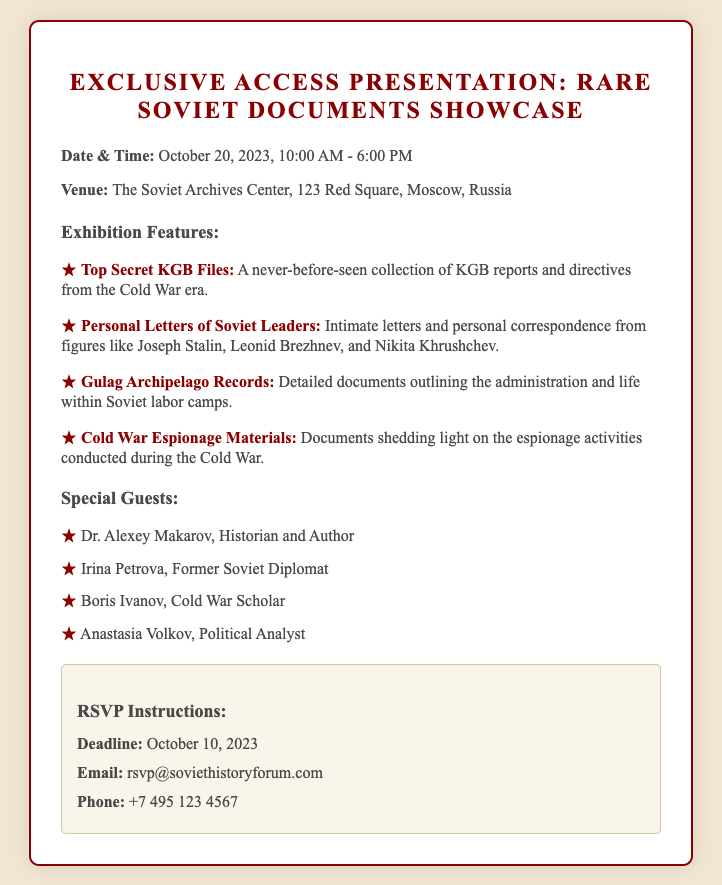what is the date of the event? The date of the event is explicitly stated in the document.
Answer: October 20, 2023 what time does the exhibition start? The exhibition hours are listed at the beginning of the document.
Answer: 10:00 AM who is one of the special guests? The document lists several special guests in a bullet format.
Answer: Dr. Alexey Makarov what type of documents are featured in the exhibition? The features section describes various types of documents presented at the showcase.
Answer: KGB Files what is the RSVP deadline? The deadline for RSVPs is highlighted in the RSVP instructions section.
Answer: October 10, 2023 where is the venue located? The venue information is provided with a full address in the document.
Answer: 123 Red Square, Moscow, Russia how many special guests are listed? The number of special guests can be counted from the list given in the document.
Answer: Four what is the phone number for RSVPs? The contact information for RSVPs includes a specific phone number.
Answer: +7 495 123 4567 